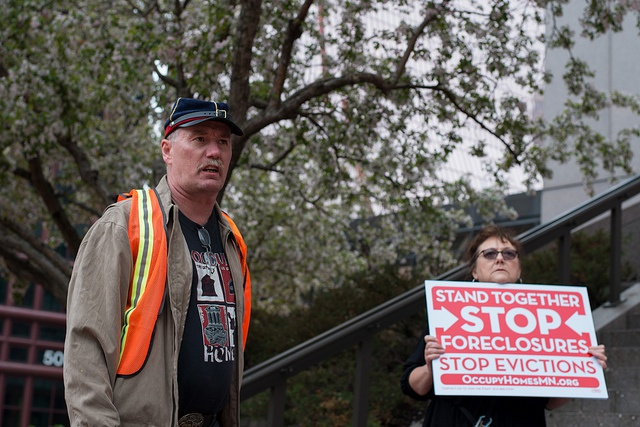Describe the objects in this image and their specific colors. I can see people in gray, black, and darkgray tones and people in gray, black, lightpink, and brown tones in this image. 